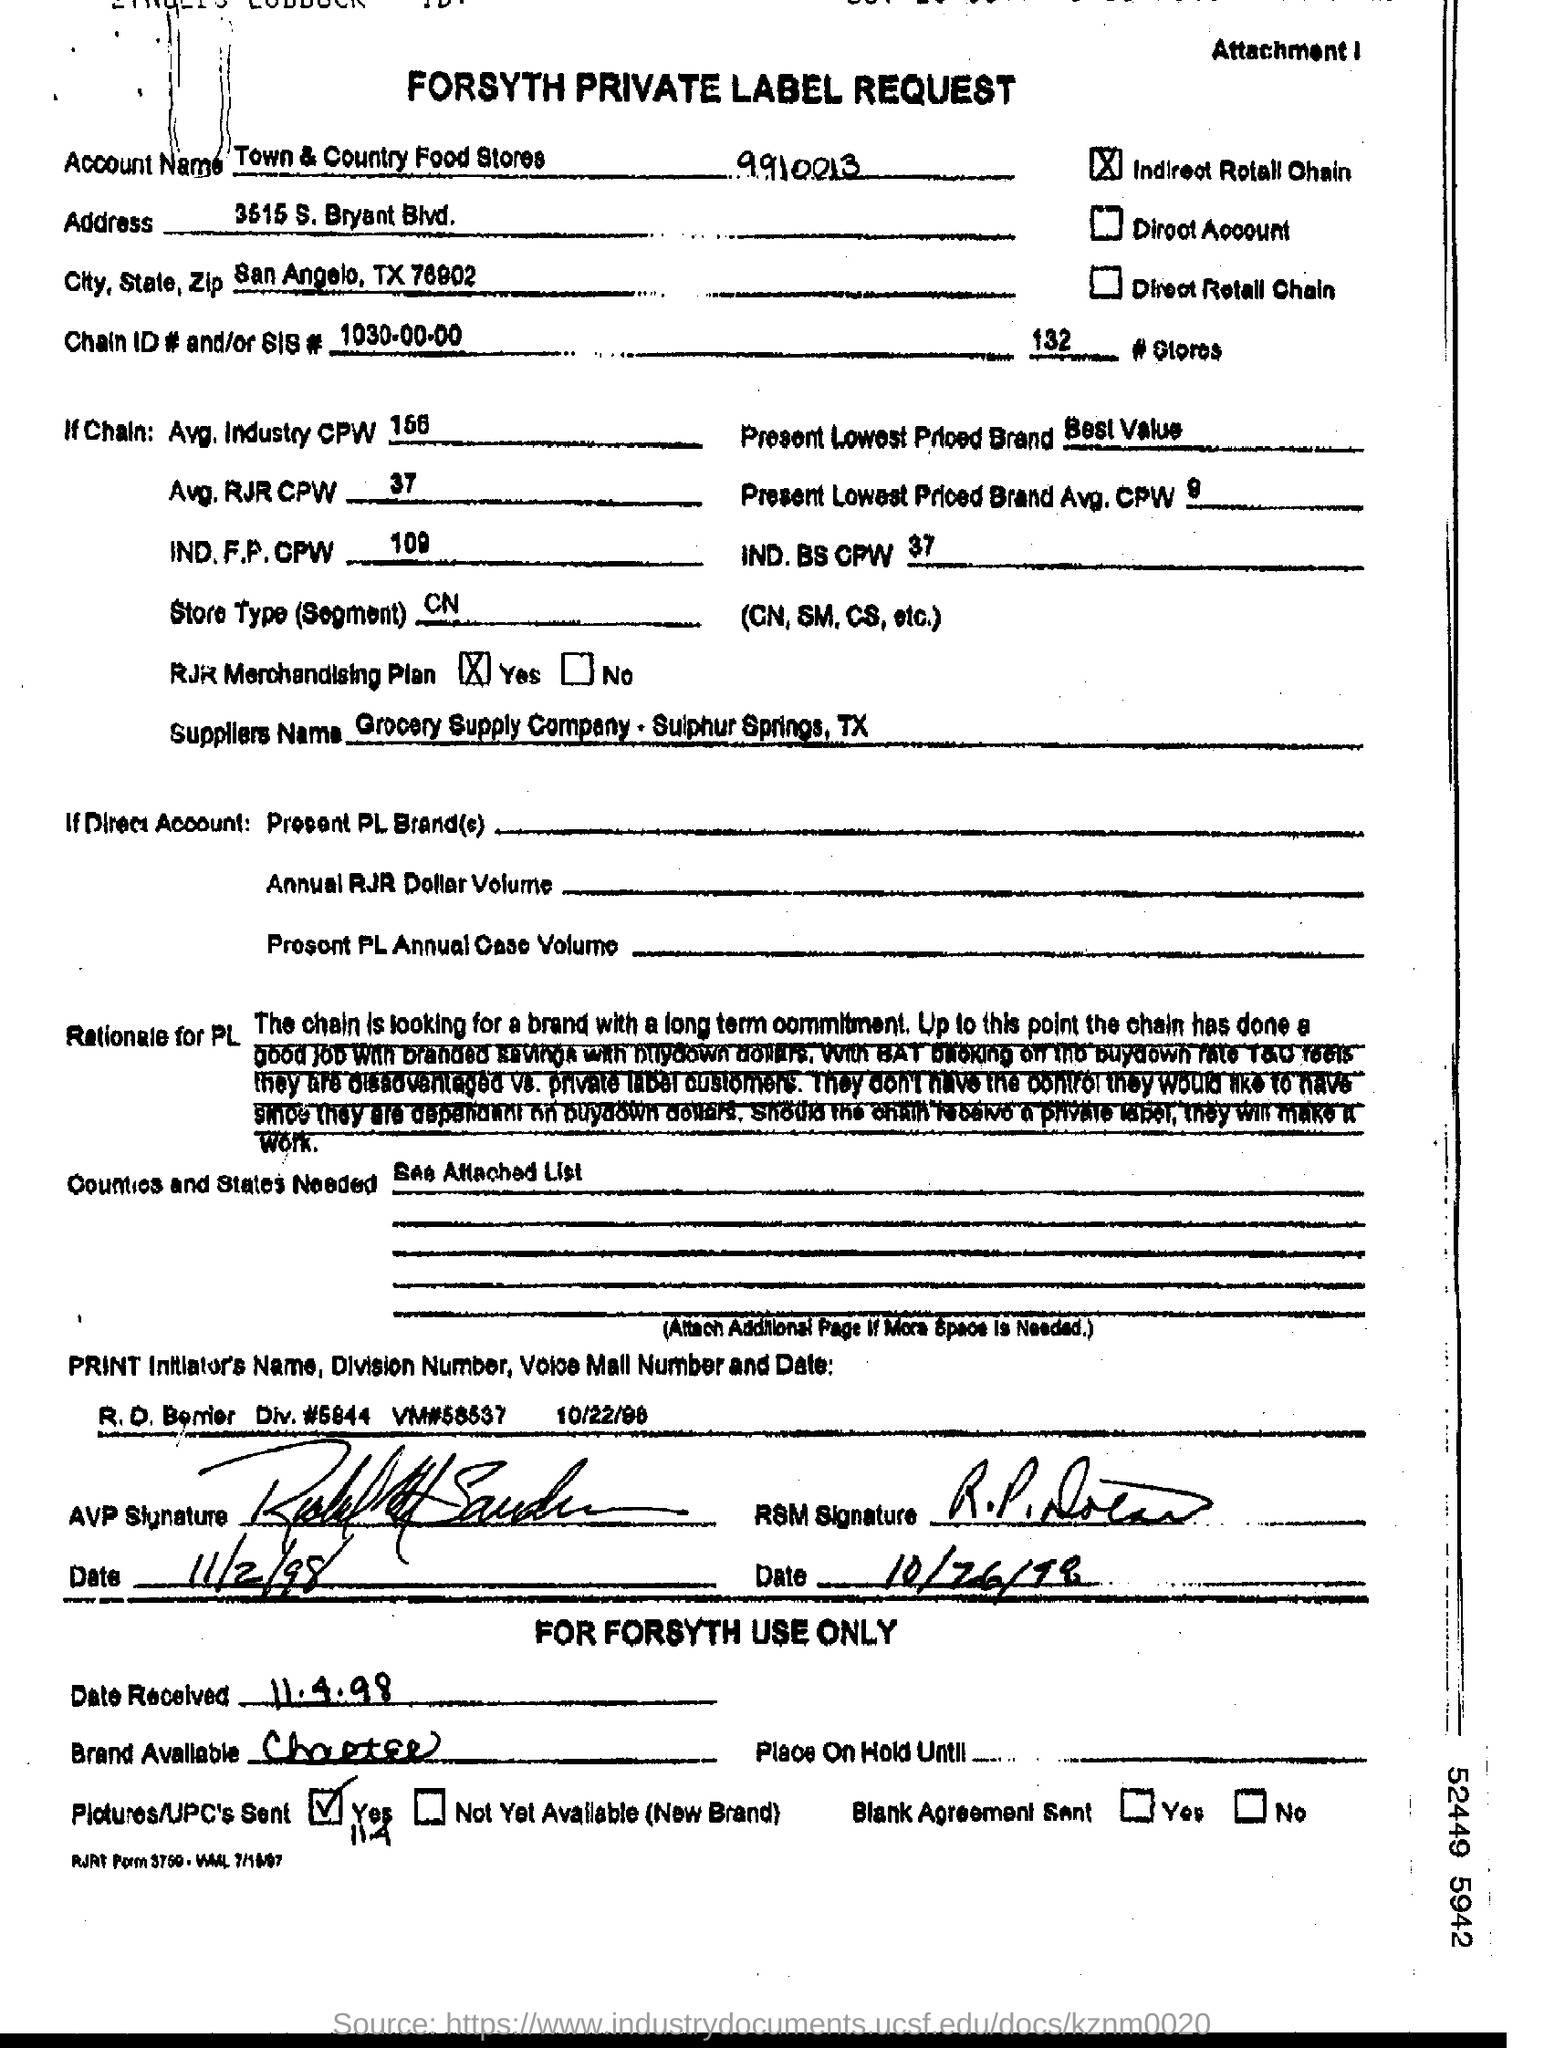Whether RJR merchandising plan is YES or NO?
Ensure brevity in your answer.  Yes. What is the Avg. Industry CPW mentioned?
Offer a terse response. 156. What is dated mentioned as date received?
Your answer should be very brief. 11.4.98. 